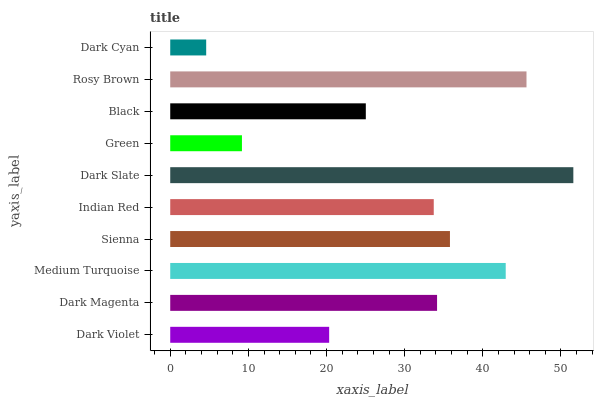Is Dark Cyan the minimum?
Answer yes or no. Yes. Is Dark Slate the maximum?
Answer yes or no. Yes. Is Dark Magenta the minimum?
Answer yes or no. No. Is Dark Magenta the maximum?
Answer yes or no. No. Is Dark Magenta greater than Dark Violet?
Answer yes or no. Yes. Is Dark Violet less than Dark Magenta?
Answer yes or no. Yes. Is Dark Violet greater than Dark Magenta?
Answer yes or no. No. Is Dark Magenta less than Dark Violet?
Answer yes or no. No. Is Dark Magenta the high median?
Answer yes or no. Yes. Is Indian Red the low median?
Answer yes or no. Yes. Is Green the high median?
Answer yes or no. No. Is Medium Turquoise the low median?
Answer yes or no. No. 